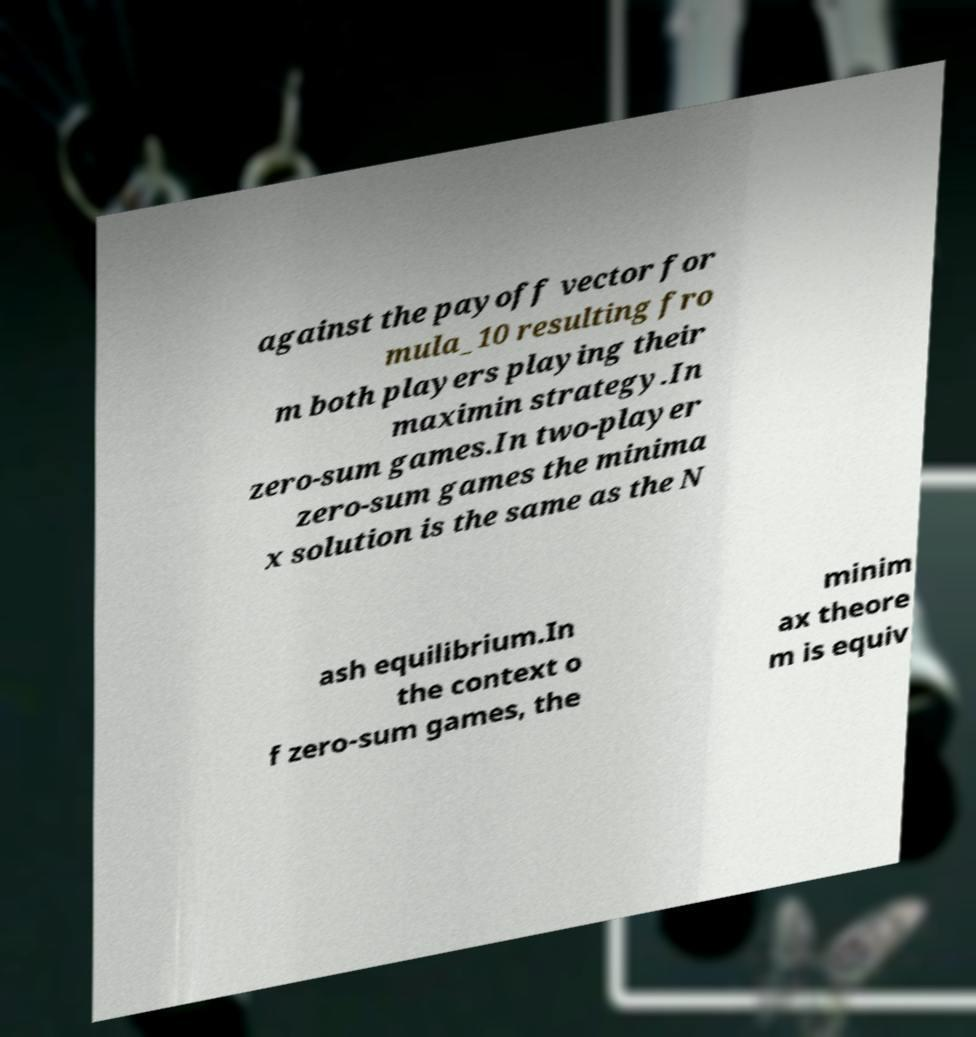Can you accurately transcribe the text from the provided image for me? against the payoff vector for mula_10 resulting fro m both players playing their maximin strategy.In zero-sum games.In two-player zero-sum games the minima x solution is the same as the N ash equilibrium.In the context o f zero-sum games, the minim ax theore m is equiv 